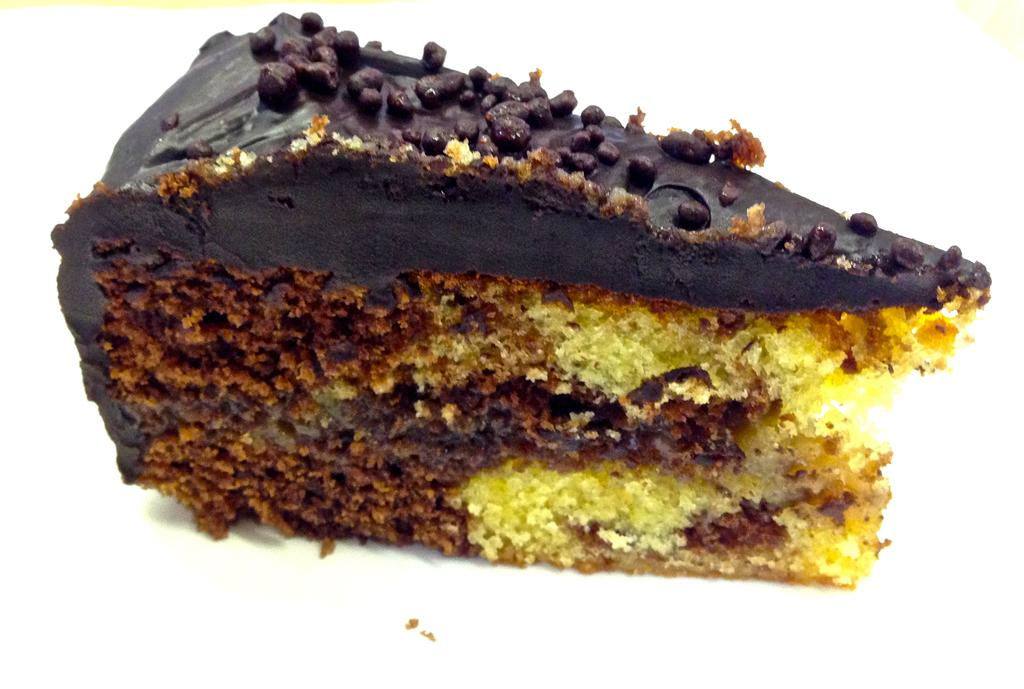What is the main subject of the image? There is a food item in the image. What color is the background of the image? The background of the image is white. What type of iron is being used by the society in the image? There is no iron or society present in the image; it features a food item against a white background. How does the loss of the food item affect the people in the image? There is no indication of loss or people in the image; it only shows a food item against a white background. 